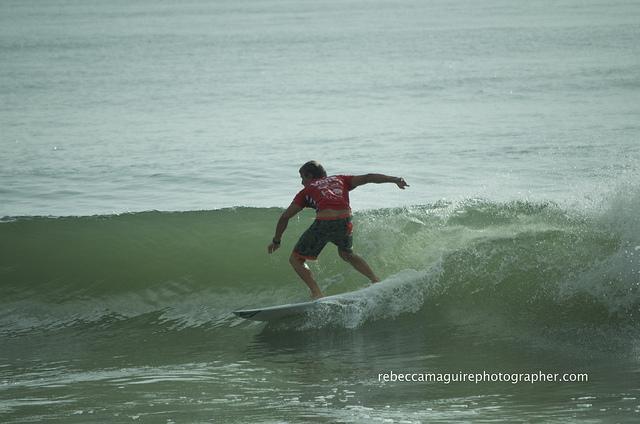What is the person doing?
Be succinct. Surfing. What tint of blue is the wave the man is on?
Quick response, please. Green. Why is this person wearing a wetsuit?
Keep it brief. Surfing. What color is the water?
Quick response, please. Green. What color is the surfboard?
Concise answer only. White. What gender is the surfer?
Short answer required. Male. Is this person wearing a wetsuit?
Quick response, please. No. How many people are in this picture?
Short answer required. 1. Is the man brushing his teeth?
Concise answer only. No. What is the volatility of the wave?
Short answer required. Medium. Is the person wearing shorts?
Answer briefly. Yes. What is the person in the photo holding?
Give a very brief answer. Nothing. Is the man going to hit the wave?
Give a very brief answer. Yes. Is the surfer wearing a shirt?
Concise answer only. Yes. Is the person wearing a shirt?
Write a very short answer. Yes. 